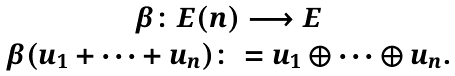<formula> <loc_0><loc_0><loc_500><loc_500>\begin{array} { c c } \beta \colon E ( n ) \longrightarrow E \\ \beta ( u _ { 1 } + \cdots + u _ { n } ) \colon = u _ { 1 } \oplus \cdots \oplus u _ { n } . \end{array}</formula> 